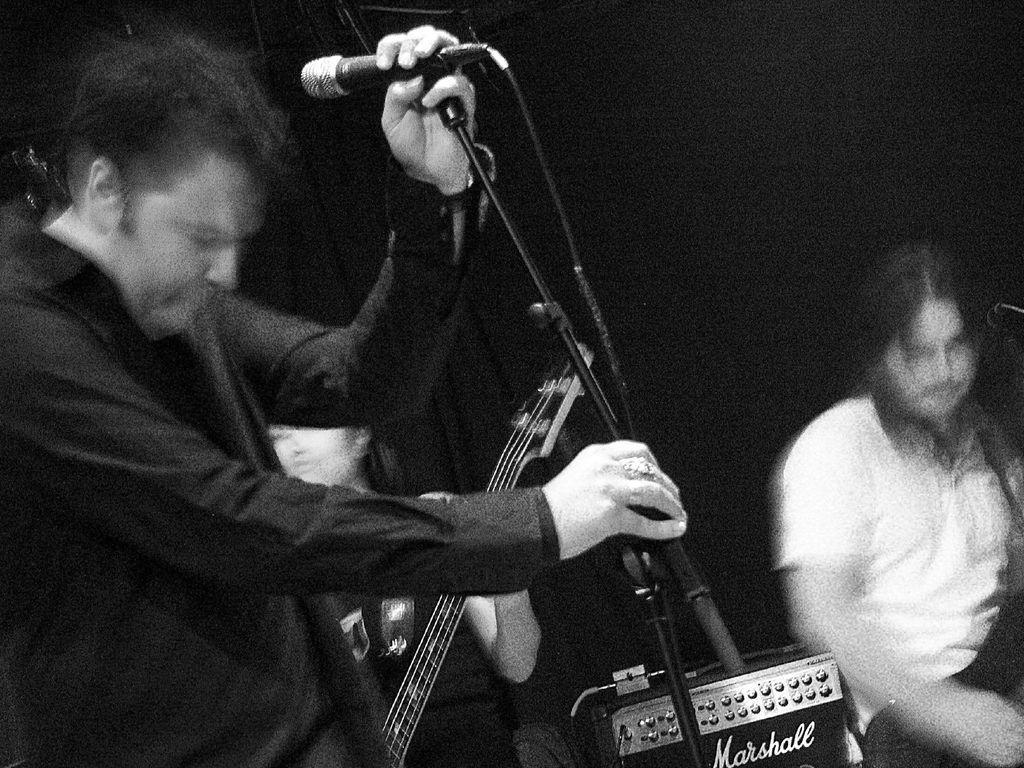Can you describe this image briefly? A black and white picture. This person is standing and holds a mic and holder. Backside of this person there is a woman is standing and holds a guitar. This person is sitting on a chair. 